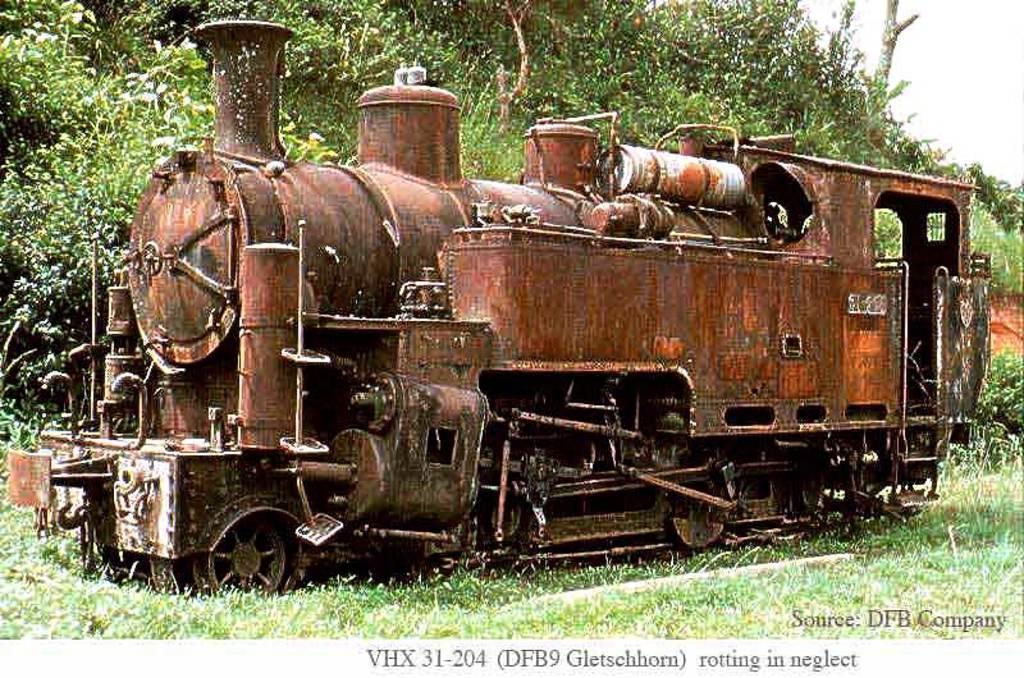Could you give a brief overview of what you see in this image? In this picture we can see a train on the grass. There are a few plants visible in the background. We can some text at the bottom of the picture. 